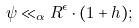<formula> <loc_0><loc_0><loc_500><loc_500>\psi \ll _ { \alpha } R ^ { \epsilon } \cdot ( 1 + h ) ;</formula> 